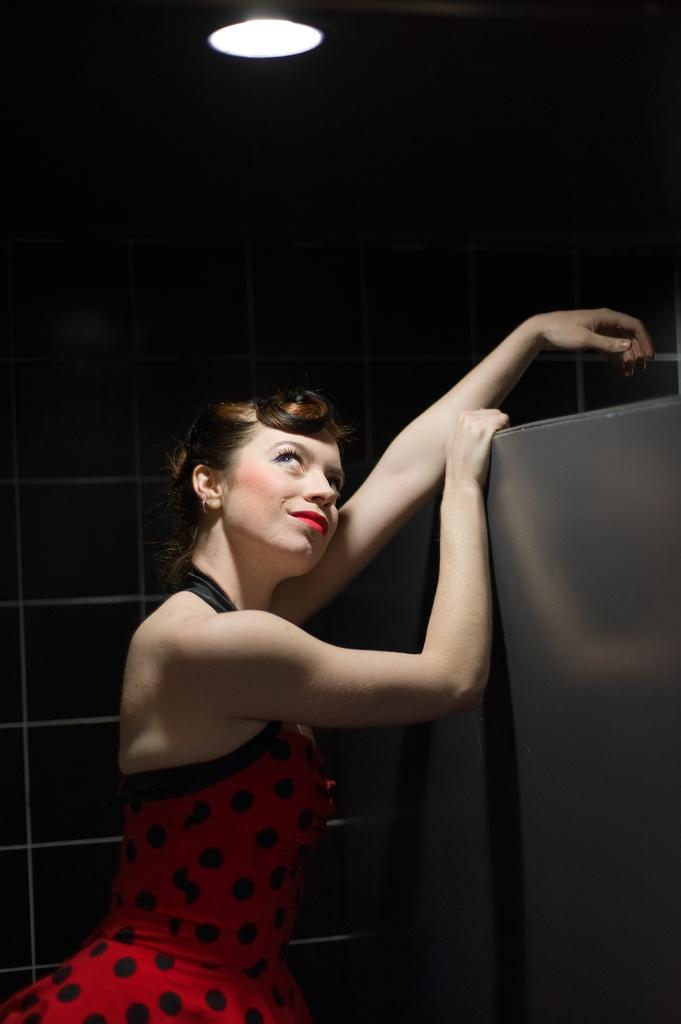Who is on the left side of the image? There is a woman in a red dress on the left side of the image. What can be seen on the right side of the image? There is an iron object on the right side of the image. What is in the background of the image? There is a well in the background of the image. What is visible at the top of the image? There is light visible at the top of the image. What type of zinc object is present in the image? There is no zinc object present in the image. Can you tell me how much the woman's haircut costs in the image? There is no information about the cost of a haircut in the image. 